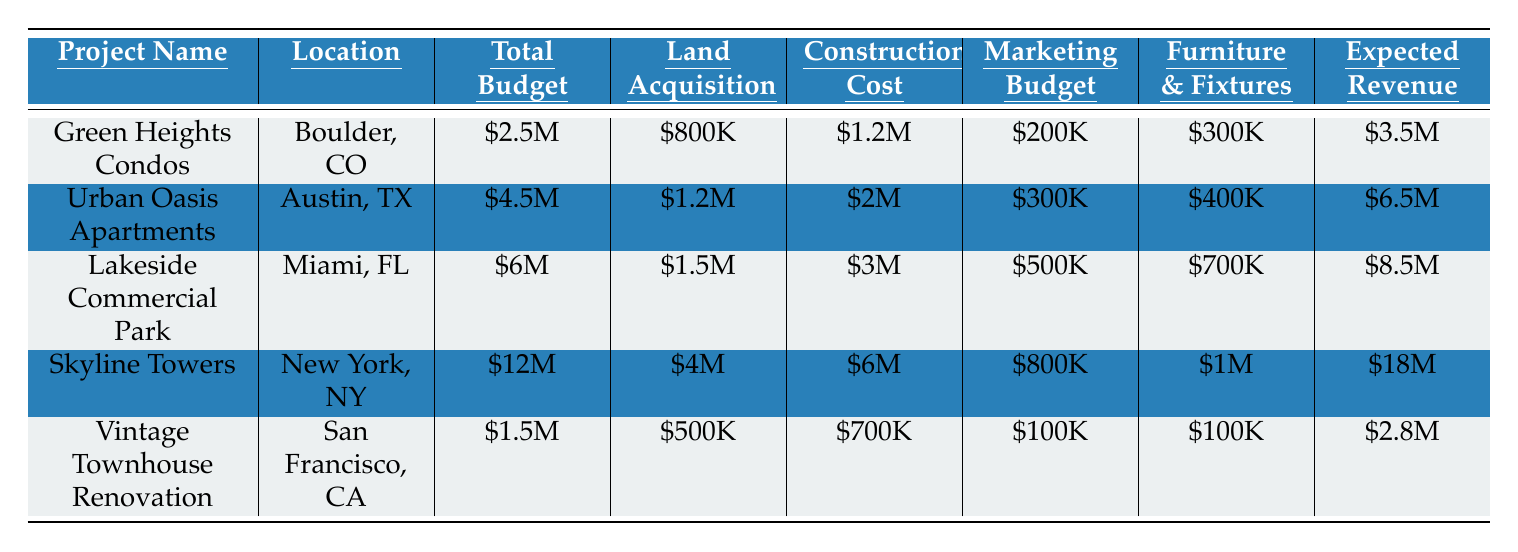What is the total budget for the Skyline Towers project? In the table, the total budget for the Skyline Towers is listed under the "Total Budget" column. It is specified as \$12 million.
Answer: \$12M What is the expected revenue for the Lakeside Commercial Park? The expected revenue can be found in the "Expected Revenue" column for the Lakeside Commercial Park project, which shows \$8.5 million.
Answer: \$8.5M Which project has the highest land acquisition cost? By comparing the "Land Acquisition" amounts across all projects, Skyline Towers has \$4 million, which is higher than all other projects.
Answer: Skyline Towers What is the total construction cost for all projects combined? We add the construction costs of all projects: \$1.2M + \$2M + \$3M + \$6M + \$700K = \$13.9M.
Answer: \$13.9M Is the marketing budget for Urban Oasis Apartments greater than the marketing budget for Vintage Townhouse Renovation? The marketing budget for Urban Oasis Apartments is \$300K and for Vintage Townhouse Renovation is \$100K; since \$300K is greater than \$100K, the statement is true.
Answer: Yes What is the difference in total budget between Lakeside Commercial Park and Green Heights Condos? The total budget for Lakeside Commercial Park is \$6M and for Green Heights Condos is \$2.5M. The difference is \$6M - \$2.5M = \$3.5M.
Answer: \$3.5M Which project has the lowest expected revenue, and what is that amount? Looking at the "Expected Revenue" column, Vintage Townhouse Renovation has the lowest value at \$2.8 million.
Answer: Vintage Townhouse Renovation, \$2.8M What is the average furniture and fixtures budget across all projects? The budgets for furniture and fixtures are \$300K, \$400K, \$700K, \$1M, and \$100K. The total is \$2.5M, and with 5 projects, the average is \$2.5M / 5 = \$500K.
Answer: \$500K Do any projects have a contingency fund that exceeds \$500K? Reviewing the "Contingency Fund" amounts reveals that only Skyline Towers and Lakeside Commercial Park have contingency funds of \$800K and \$500K, respectively; thus, yes, Skyline Towers exceeds \$500K.
Answer: Yes What percentage of the total budget for Green Heights Condos is allocated to construction costs? The construction cost is \$1.2M out of a total budget of \$2.5M for Green Heights Condos. The percentage is (\$1.2M / \$2.5M) * 100 = 48%.
Answer: 48% 